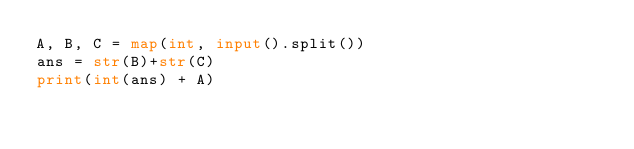<code> <loc_0><loc_0><loc_500><loc_500><_Python_>A, B, C = map(int, input().split())
ans = str(B)+str(C)
print(int(ans) + A)</code> 